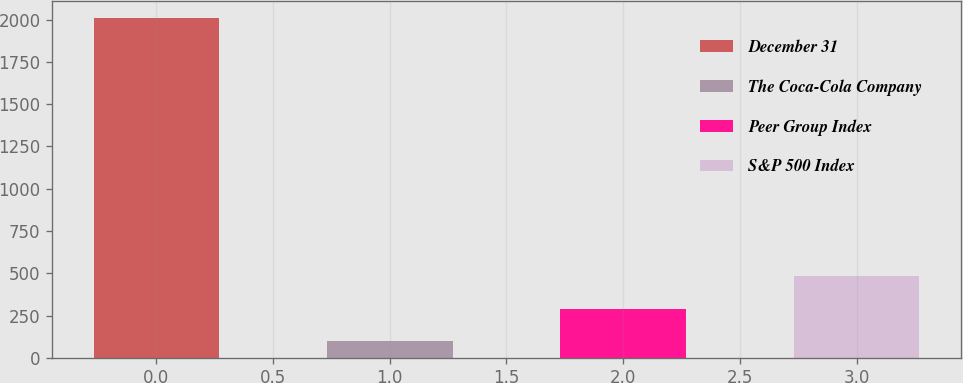Convert chart. <chart><loc_0><loc_0><loc_500><loc_500><bar_chart><fcel>December 31<fcel>The Coca-Cola Company<fcel>Peer Group Index<fcel>S&P 500 Index<nl><fcel>2008<fcel>100<fcel>290.8<fcel>481.6<nl></chart> 